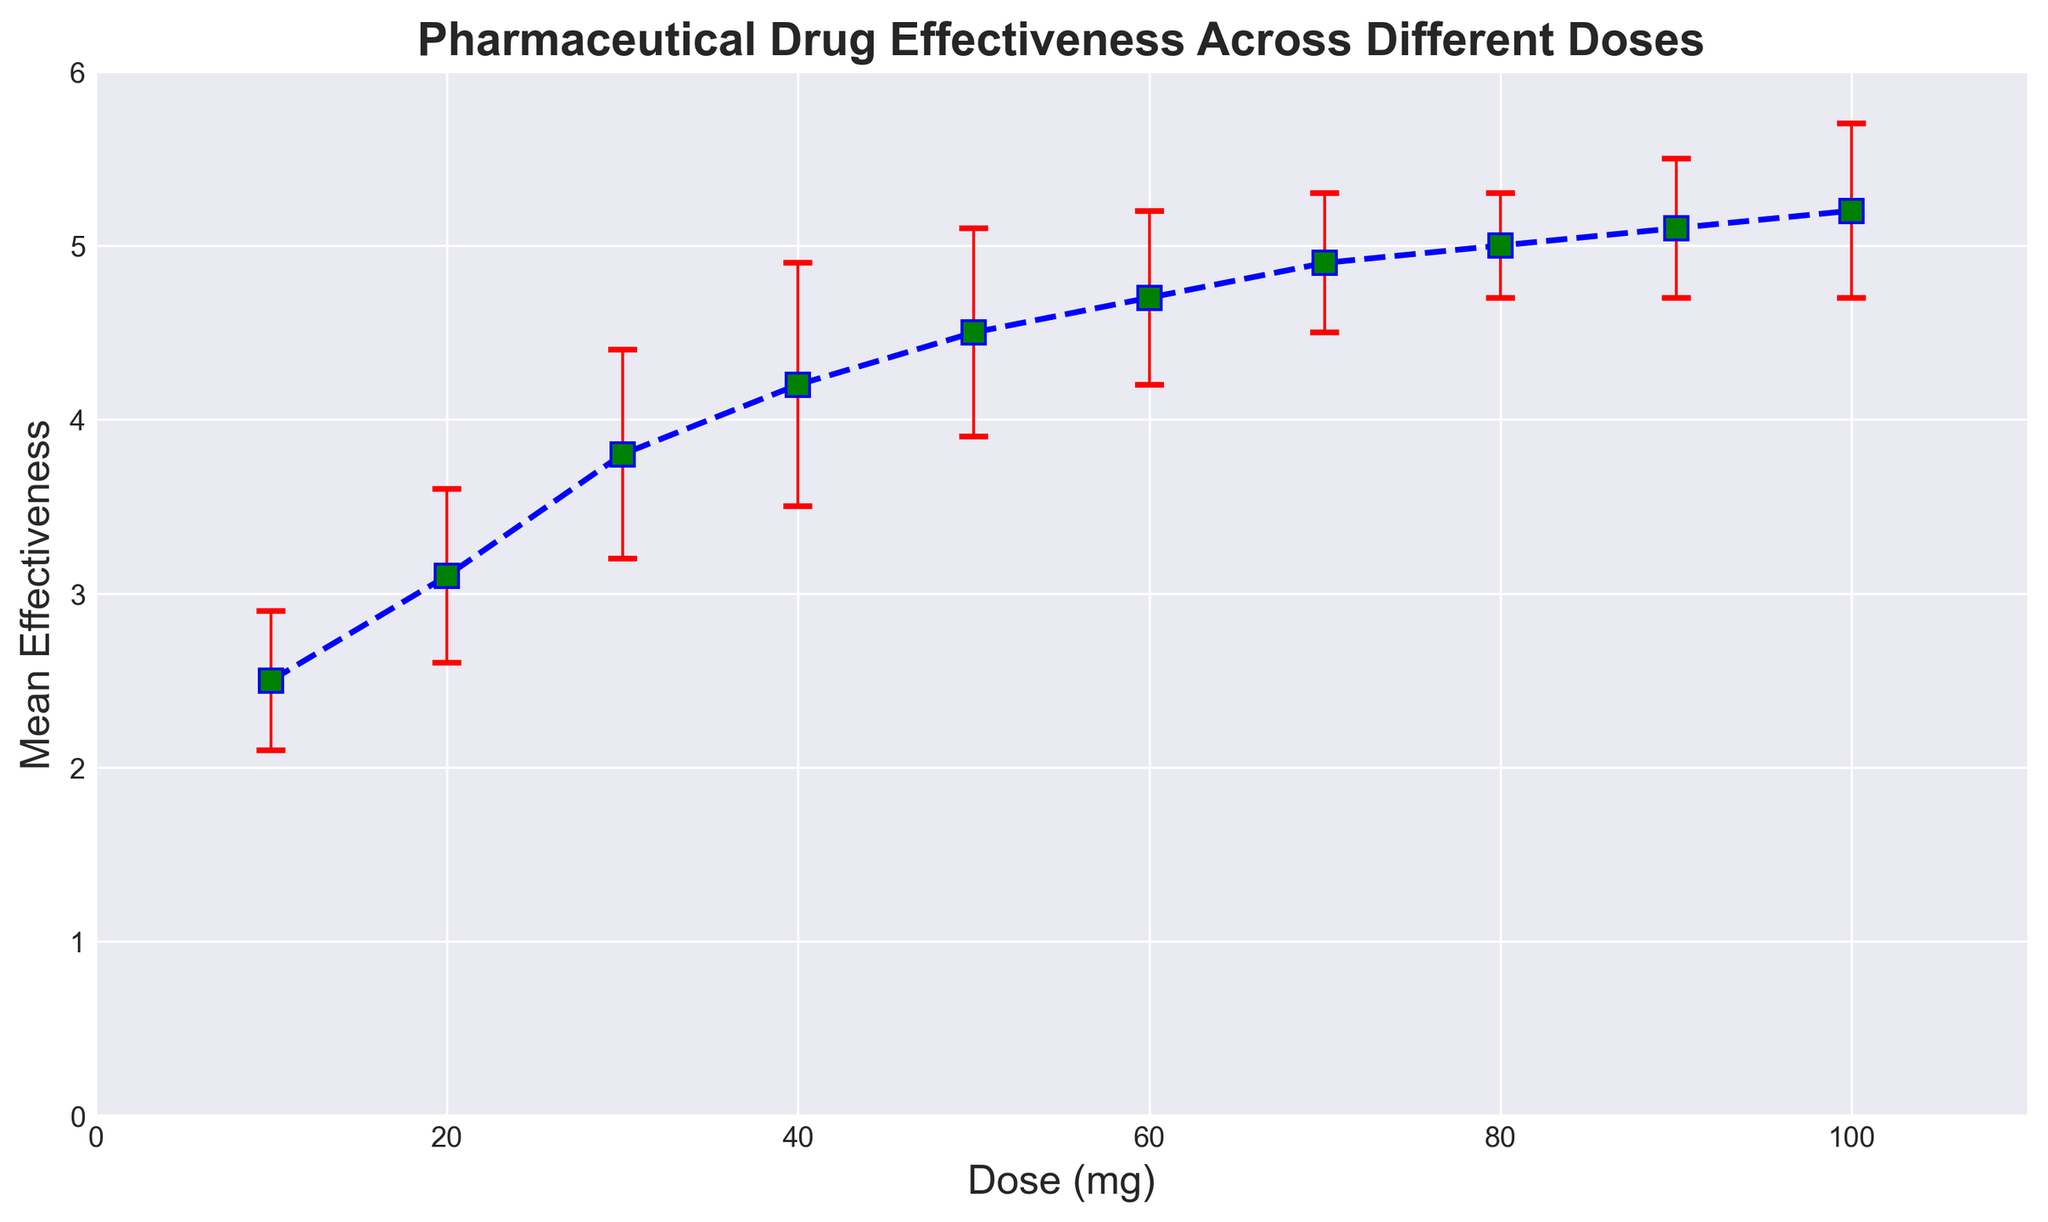What is the mean effectiveness at a dose of 60 mg? Locate the dose of 60 mg on the x-axis and then find the corresponding point on the y-axis. The mean effectiveness at 60 mg is 4.7.
Answer: 4.7 Which dose has the highest mean effectiveness? Look at the y-values for all doses and find the highest one. The highest mean effectiveness is 5.2, which corresponds to the dose of 100 mg.
Answer: 100 mg How does the mean effectiveness at 20 mg compare to that at 80 mg? Find the mean effectiveness values for 20 mg and 80 mg on the y-axis. At 20 mg, it is 3.1, and at 80 mg, it is 5.0. Therefore, the effectiveness at 80 mg is higher than at 20 mg.
Answer: Higher What is the range of mean effectiveness values shown in the plot? Identify the minimum and maximum y-values for mean effectiveness from the plot. The minimum value is 2.5 (at 10 mg), and the maximum value is 5.2 (at 100 mg). The range is the difference between these two values, which is 5.2 - 2.5 = 2.7.
Answer: 2.7 What is the standard error at a dose of 40 mg? Locate the dose of 40 mg on the x-axis and observe the error bar length. The standard error at 40 mg corresponds to the red error bar, which has a value of 0.7.
Answer: 0.7 Is there any dose where the error bar is the smallest? If so, what is the dose and its error bar value? Compare the lengths of all the error bars (red bars) in the plot. The dose with the smallest error bar length is 80 mg, with a standard error of 0.3.
Answer: 80 mg, 0.3 What is the visual difference between the error bars and the data points in the plot? The error bars are represented as vertical red lines with caps at both ends, while the data points are blue squares with green fill.
Answer: Error bars: vertical red lines, Data points: blue squares with green fill Describe the general trend of pharmaceutical drug effectiveness as the dose increases. Observe the pattern of the mean effectiveness values as the dose increases from 10 mg to 100 mg. The general trend shows that mean effectiveness increases steadily with increasing dose.
Answer: Increasing trend What is the difference in mean effectiveness between the doses of 50 mg and 70 mg? Find the mean effectiveness values for 50 mg and 70 mg on the y-axis. At 50 mg, it is 4.5, and at 70 mg, it is 4.9. The difference is 4.9 - 4.5 = 0.4.
Answer: 0.4 